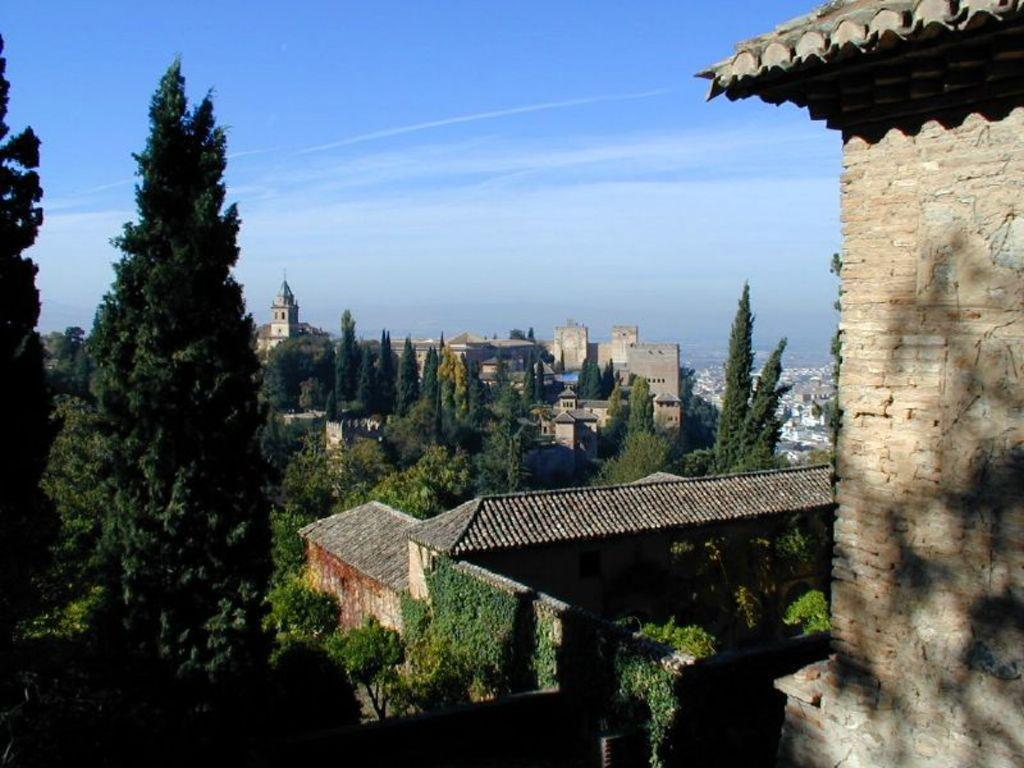What type of structures can be seen in the image? There are buildings in the image. What other natural elements are present in the image? There are trees in the image. What is visible at the top of the image? The sky is visible at the top of the image. How many sheep can be seen grazing in the image? There are no sheep present in the image; it features buildings, trees, and the sky. What type of collar is visible on the crow in the image? There is no crow or collar present in the image. 